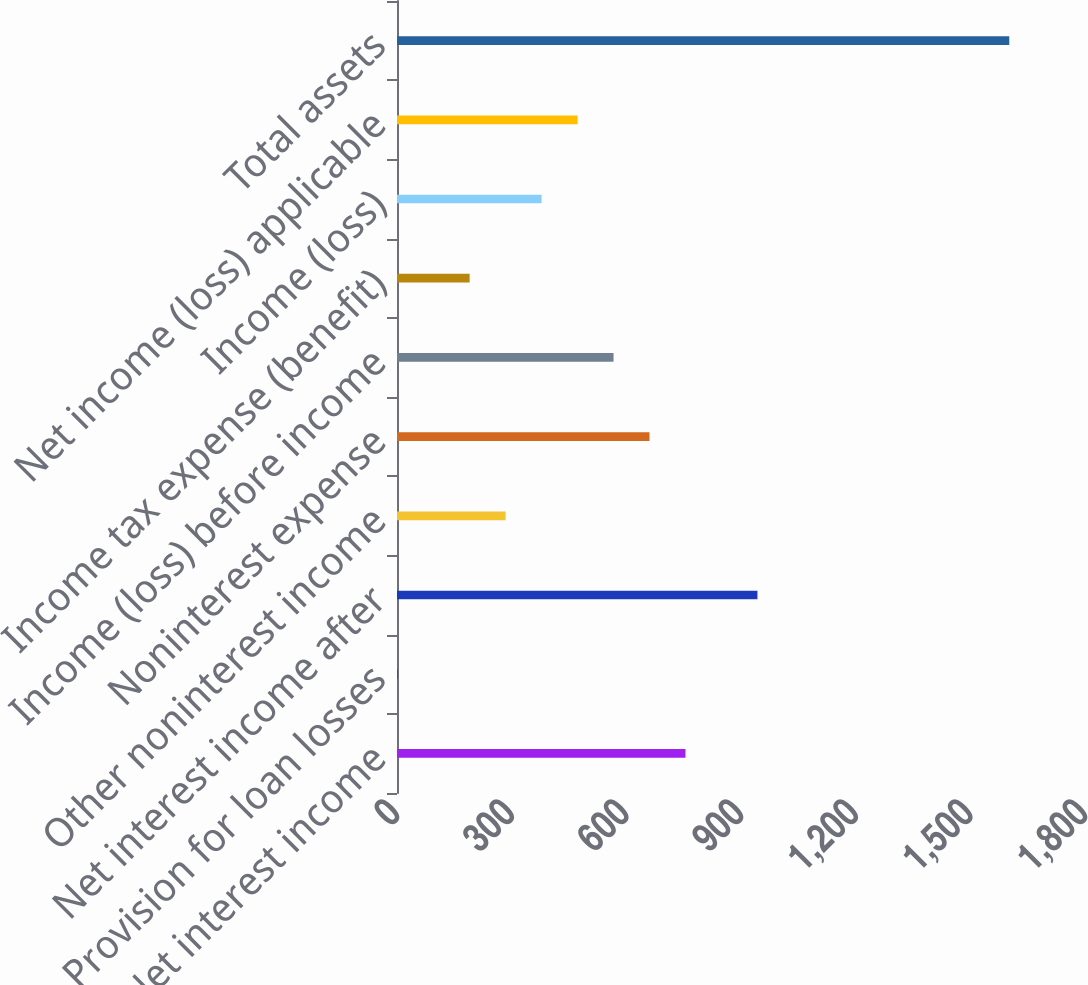<chart> <loc_0><loc_0><loc_500><loc_500><bar_chart><fcel>Net interest income<fcel>Provision for loan losses<fcel>Net interest income after<fcel>Other noninterest income<fcel>Noninterest expense<fcel>Income (loss) before income<fcel>Income tax expense (benefit)<fcel>Income (loss)<fcel>Net income (loss) applicable<fcel>Total assets<nl><fcel>754.76<fcel>1.8<fcel>943<fcel>284.16<fcel>660.64<fcel>566.52<fcel>190.04<fcel>378.28<fcel>472.4<fcel>1601.84<nl></chart> 